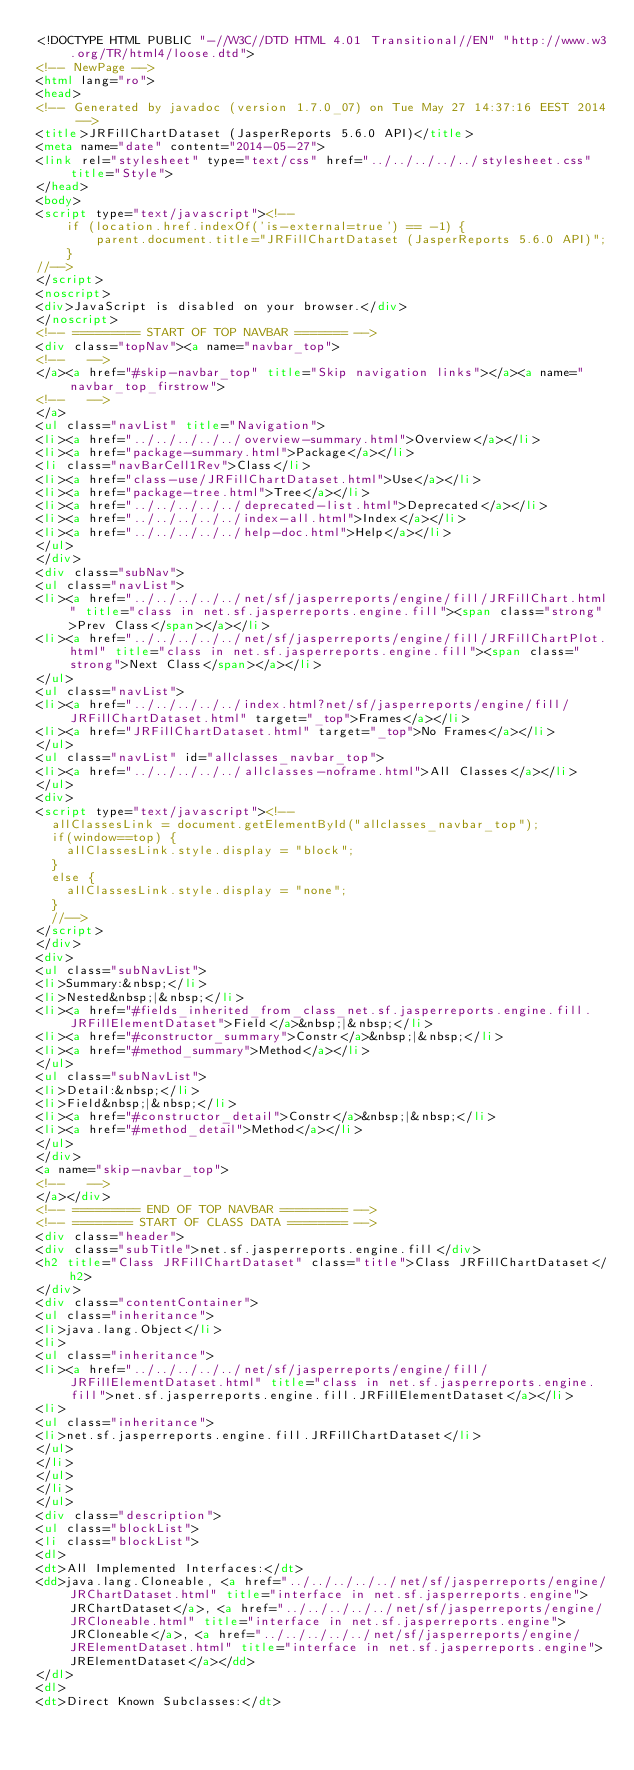<code> <loc_0><loc_0><loc_500><loc_500><_HTML_><!DOCTYPE HTML PUBLIC "-//W3C//DTD HTML 4.01 Transitional//EN" "http://www.w3.org/TR/html4/loose.dtd">
<!-- NewPage -->
<html lang="ro">
<head>
<!-- Generated by javadoc (version 1.7.0_07) on Tue May 27 14:37:16 EEST 2014 -->
<title>JRFillChartDataset (JasperReports 5.6.0 API)</title>
<meta name="date" content="2014-05-27">
<link rel="stylesheet" type="text/css" href="../../../../../stylesheet.css" title="Style">
</head>
<body>
<script type="text/javascript"><!--
    if (location.href.indexOf('is-external=true') == -1) {
        parent.document.title="JRFillChartDataset (JasperReports 5.6.0 API)";
    }
//-->
</script>
<noscript>
<div>JavaScript is disabled on your browser.</div>
</noscript>
<!-- ========= START OF TOP NAVBAR ======= -->
<div class="topNav"><a name="navbar_top">
<!--   -->
</a><a href="#skip-navbar_top" title="Skip navigation links"></a><a name="navbar_top_firstrow">
<!--   -->
</a>
<ul class="navList" title="Navigation">
<li><a href="../../../../../overview-summary.html">Overview</a></li>
<li><a href="package-summary.html">Package</a></li>
<li class="navBarCell1Rev">Class</li>
<li><a href="class-use/JRFillChartDataset.html">Use</a></li>
<li><a href="package-tree.html">Tree</a></li>
<li><a href="../../../../../deprecated-list.html">Deprecated</a></li>
<li><a href="../../../../../index-all.html">Index</a></li>
<li><a href="../../../../../help-doc.html">Help</a></li>
</ul>
</div>
<div class="subNav">
<ul class="navList">
<li><a href="../../../../../net/sf/jasperreports/engine/fill/JRFillChart.html" title="class in net.sf.jasperreports.engine.fill"><span class="strong">Prev Class</span></a></li>
<li><a href="../../../../../net/sf/jasperreports/engine/fill/JRFillChartPlot.html" title="class in net.sf.jasperreports.engine.fill"><span class="strong">Next Class</span></a></li>
</ul>
<ul class="navList">
<li><a href="../../../../../index.html?net/sf/jasperreports/engine/fill/JRFillChartDataset.html" target="_top">Frames</a></li>
<li><a href="JRFillChartDataset.html" target="_top">No Frames</a></li>
</ul>
<ul class="navList" id="allclasses_navbar_top">
<li><a href="../../../../../allclasses-noframe.html">All Classes</a></li>
</ul>
<div>
<script type="text/javascript"><!--
  allClassesLink = document.getElementById("allclasses_navbar_top");
  if(window==top) {
    allClassesLink.style.display = "block";
  }
  else {
    allClassesLink.style.display = "none";
  }
  //-->
</script>
</div>
<div>
<ul class="subNavList">
<li>Summary:&nbsp;</li>
<li>Nested&nbsp;|&nbsp;</li>
<li><a href="#fields_inherited_from_class_net.sf.jasperreports.engine.fill.JRFillElementDataset">Field</a>&nbsp;|&nbsp;</li>
<li><a href="#constructor_summary">Constr</a>&nbsp;|&nbsp;</li>
<li><a href="#method_summary">Method</a></li>
</ul>
<ul class="subNavList">
<li>Detail:&nbsp;</li>
<li>Field&nbsp;|&nbsp;</li>
<li><a href="#constructor_detail">Constr</a>&nbsp;|&nbsp;</li>
<li><a href="#method_detail">Method</a></li>
</ul>
</div>
<a name="skip-navbar_top">
<!--   -->
</a></div>
<!-- ========= END OF TOP NAVBAR ========= -->
<!-- ======== START OF CLASS DATA ======== -->
<div class="header">
<div class="subTitle">net.sf.jasperreports.engine.fill</div>
<h2 title="Class JRFillChartDataset" class="title">Class JRFillChartDataset</h2>
</div>
<div class="contentContainer">
<ul class="inheritance">
<li>java.lang.Object</li>
<li>
<ul class="inheritance">
<li><a href="../../../../../net/sf/jasperreports/engine/fill/JRFillElementDataset.html" title="class in net.sf.jasperreports.engine.fill">net.sf.jasperreports.engine.fill.JRFillElementDataset</a></li>
<li>
<ul class="inheritance">
<li>net.sf.jasperreports.engine.fill.JRFillChartDataset</li>
</ul>
</li>
</ul>
</li>
</ul>
<div class="description">
<ul class="blockList">
<li class="blockList">
<dl>
<dt>All Implemented Interfaces:</dt>
<dd>java.lang.Cloneable, <a href="../../../../../net/sf/jasperreports/engine/JRChartDataset.html" title="interface in net.sf.jasperreports.engine">JRChartDataset</a>, <a href="../../../../../net/sf/jasperreports/engine/JRCloneable.html" title="interface in net.sf.jasperreports.engine">JRCloneable</a>, <a href="../../../../../net/sf/jasperreports/engine/JRElementDataset.html" title="interface in net.sf.jasperreports.engine">JRElementDataset</a></dd>
</dl>
<dl>
<dt>Direct Known Subclasses:</dt></code> 